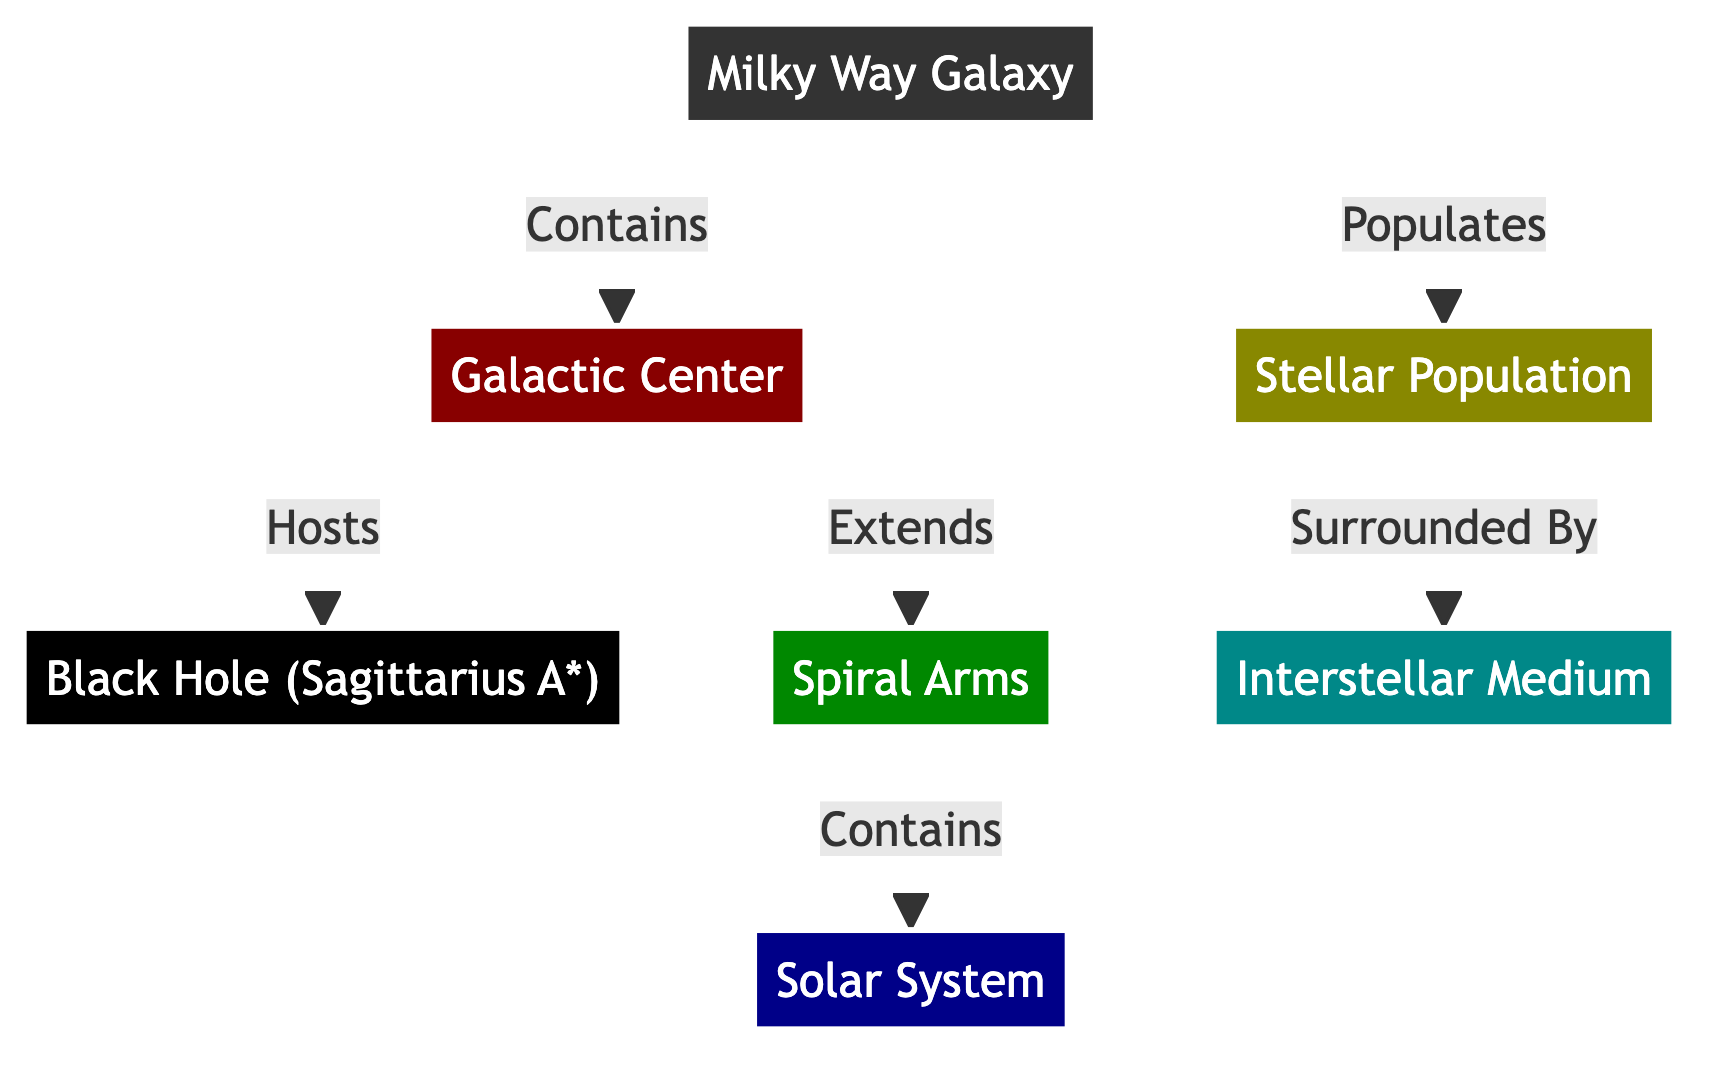What is at the center of the Milky Way Galaxy? The diagram indicates that the Galactic Center contains a Black Hole, specifically Sagittarius A*. Therefore, the center element "Galactic Center" leads to the "Black Hole" node, confirming that Sagittarius A* is the answer.
Answer: Black Hole (Sagittarius A*) How many spiral arms are shown in the Milky Way Galaxy? The diagram lists "Spiral Arms" as a single node leading to the "Solar System" node. There is only one instance of the Spiral Arms node, indicating that only one representation exists in this diagram.
Answer: 1 Which component is surrounded by the Interstellar Medium? The diagram depicts the Stellar Population leading to the Interstellar Medium, indicating that the Stellar Population is surrounded by it. Thus, we can conclude that the node directly associated with the Interstellar Medium is the Stellar Population.
Answer: Stellar Population What does the Milky Way Galaxy populate? The diagram shows that the Milky Way Galaxy "Populates" the Stellar Population, establishing a direct relationship. By interpreting this link, we determine that it refers to the entities that populate the galaxy.
Answer: Stellar Population Which part of the Milky Way Galaxy extends from the Galactic Center? The diagram illustrates that the Galactic Center is connected to the Spiral Arms, indicating that the Spiral Arms are the portion that extends from the Galactic Center. Thus, this node must be the answer to the question.
Answer: Spiral Arms What hosts Sagittarius A*? According to the diagram, the Galactic Center is the host of the Black Hole (Sagittarius A*), establishing a clear relationship where the Galactic Center directly contains and hosts this black hole.
Answer: Galactic Center 